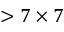Convert formula to latex. <formula><loc_0><loc_0><loc_500><loc_500>> 7 \times 7</formula> 